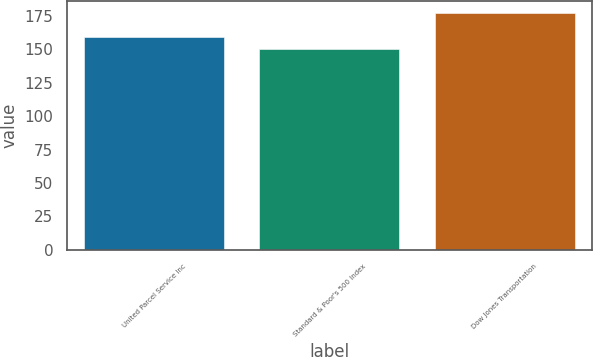<chart> <loc_0><loc_0><loc_500><loc_500><bar_chart><fcel>United Parcel Service Inc<fcel>Standard & Poor's 500 Index<fcel>Dow Jones Transportation<nl><fcel>159.23<fcel>150.49<fcel>176.83<nl></chart> 